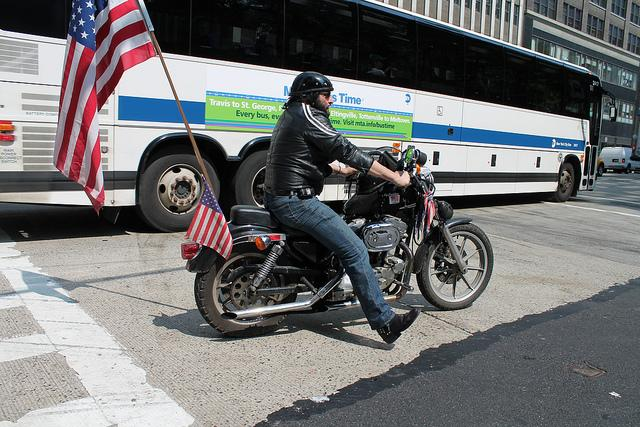Which one of these terms could be used to describe the motorcycle rider? Please explain your reasoning. patriotic. The motorcycle rider has multiple american flags to showcase their loyalty. 